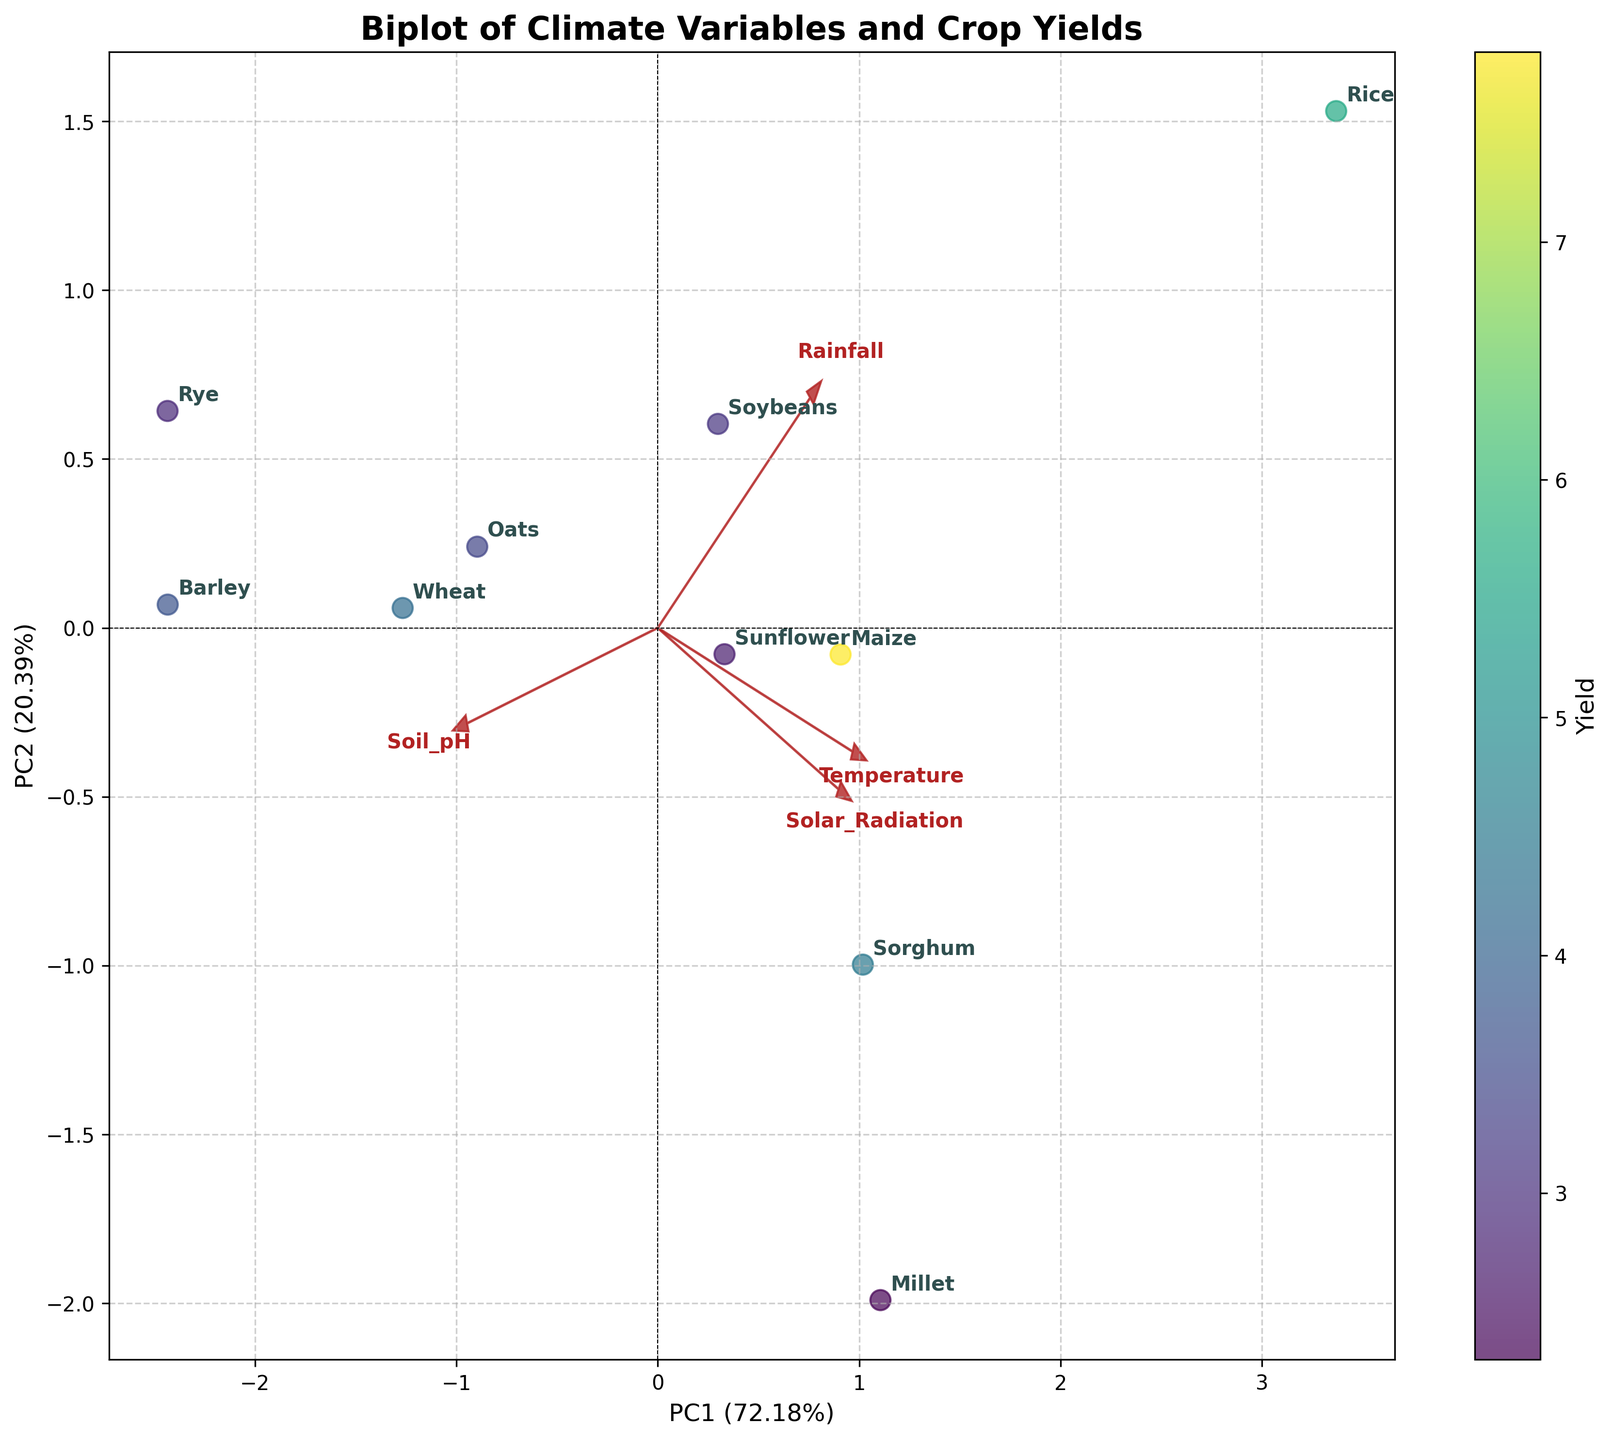how many axes does the figure have? The figure has two main axes, labeled as PC1 and PC2, which represent the first and second principal components from the PCA analysis.
Answer: 2 what's the total explained variance by the first two principal components? The explained variance is shown on the labels of the PC1 and PC2 axes in percentages. Adding them up gives the total explained variance. Let's say PC1 explains 58% and PC2 explains 25%; the total explained variance would be 58% + 25% = 83%.
Answer: 83% which crop is located the farthest right on the PC1 axis? By looking at the rightmost point along the PC1 axis, we identify the crop located the farthest to the right.
Answer: Millet what is the general direction of the 'Solar Radiation' vector in the plot? The 'Solar Radiation' vector is represented by an arrow. To determine its general direction, observe where the arrow points relative to the origin.
Answer: Up and right how does wheat compare to barley in terms of yield? We need to compare the color representing yield for both Wheat and Barley. Wheat appears in a color representing higher yield compared to Barley according to the color scale.
Answer: Wheat has a higher yield than Barley which variable has the longest vector in the biplot? The length of the vectors representing variables indicates the magnitude of their contribution to the principal components. The longest vector is the arrow with the greater length from the origin.
Answer: Rainfall what trends can you observe regarding 'Temperature' and crop yields? First, observe the direction of the 'Temperature' vector and then look at the crops projected in that direction alongside their yield colors for a trend.
Answer: Higher Temperature is generally associated with higher yields are crops with lower soil pH clustered together or spread out in the plot? Observe the positions of crops that have lower soil pH values and determine if they are closely located or dispersed throughout the plot.
Answer: Spread out which two climate variables are most strongly correlated? The strength of correlation between variables can be inferred from the angles between vectors; smaller angles indicate stronger positive correlation.
Answer: Temperature and Solar Radiation is there any crop located near the origin? If so, which one? Check for any crop points plotted close to the center of the origin in the figure.
Answer: Sunflower 